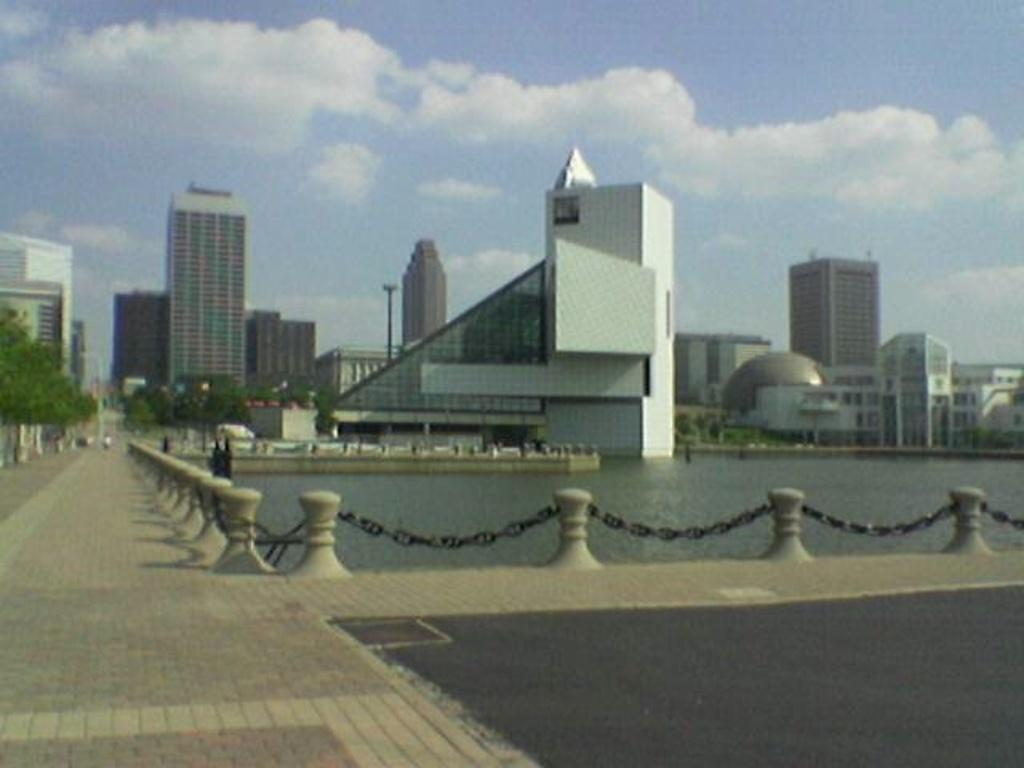What can be seen in the foreground of the image? There is a path in the image. What is visible behind the fencing in the image? There is a water surface behind the fencing. What can be seen in the distance in the image? There are many buildings and other architectures in the background of the image. What type of treatment is being administered to the buildings in the image? There is no treatment being administered to the buildings in the image; they are simply visible in the background. 